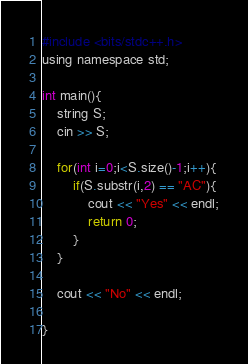<code> <loc_0><loc_0><loc_500><loc_500><_Python_>#include <bits/stdc++.h>
using namespace std;
 
int main(){
    string S;
    cin >> S;
    
    for(int i=0;i<S.size()-1;i++){
        if(S.substr(i,2) == "AC"){
            cout << "Yes" << endl;
            return 0;
        }
    }
    
    cout << "No" << endl;

}</code> 